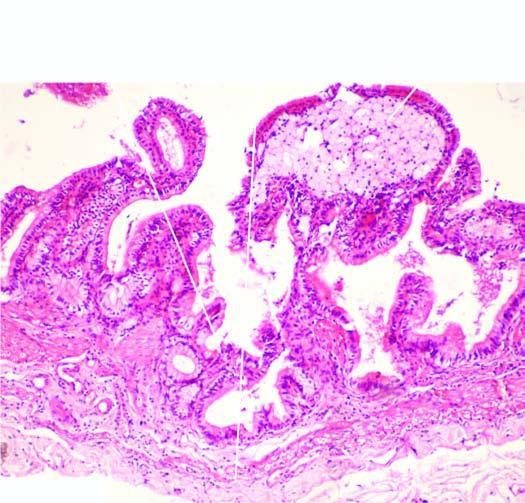does 'triple response ' show foamy macrophages?
Answer the question using a single word or phrase. No 